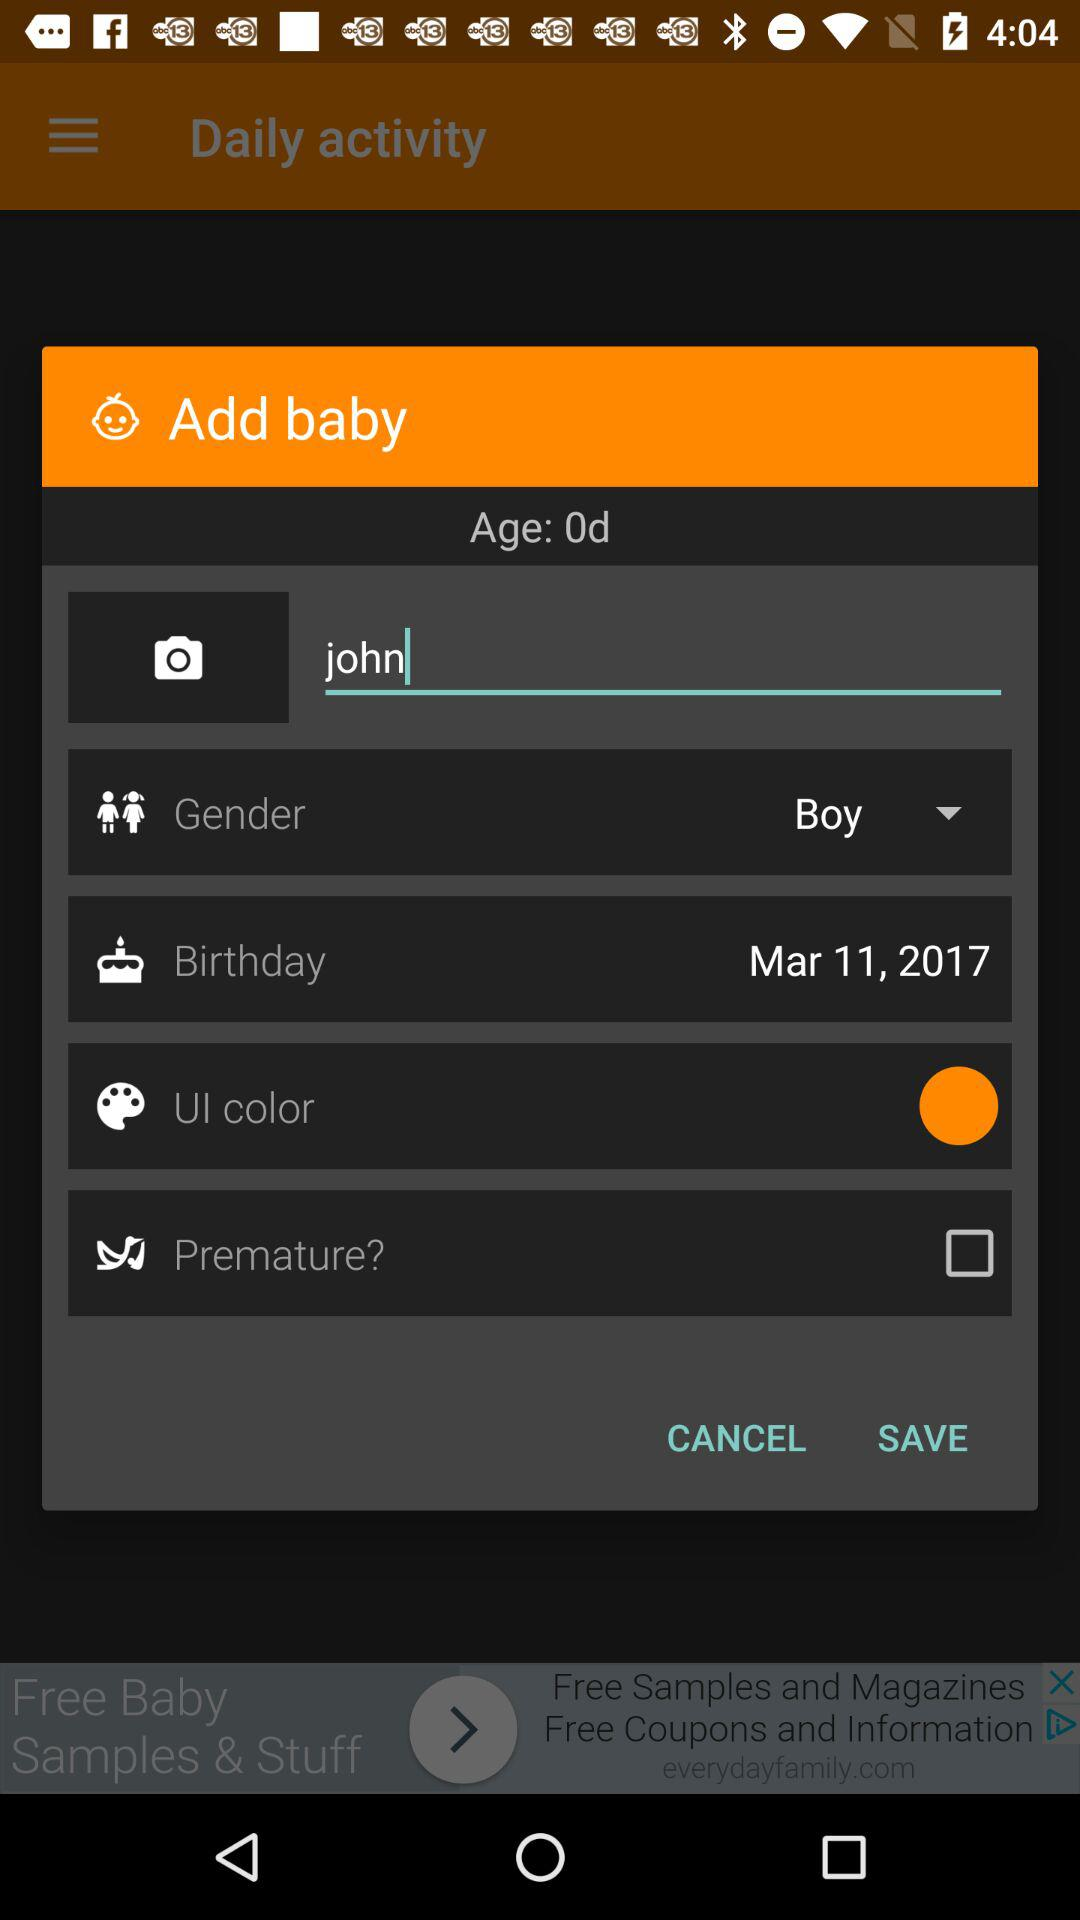What is the UI color?
When the provided information is insufficient, respond with <no answer>. <no answer> 